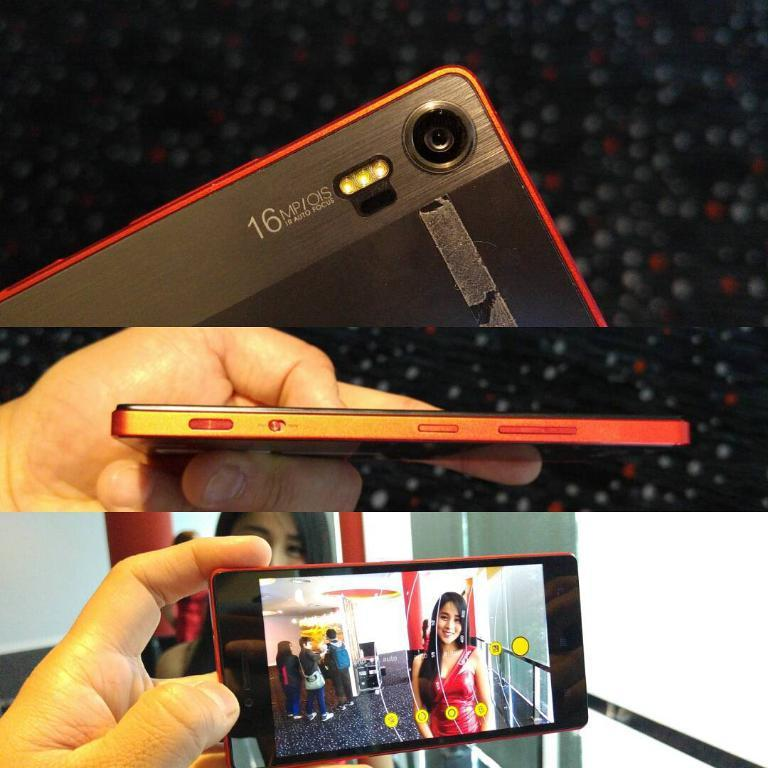Provide a one-sentence caption for the provided image. A red and black phone that as a  16 MP/OIS camera. 